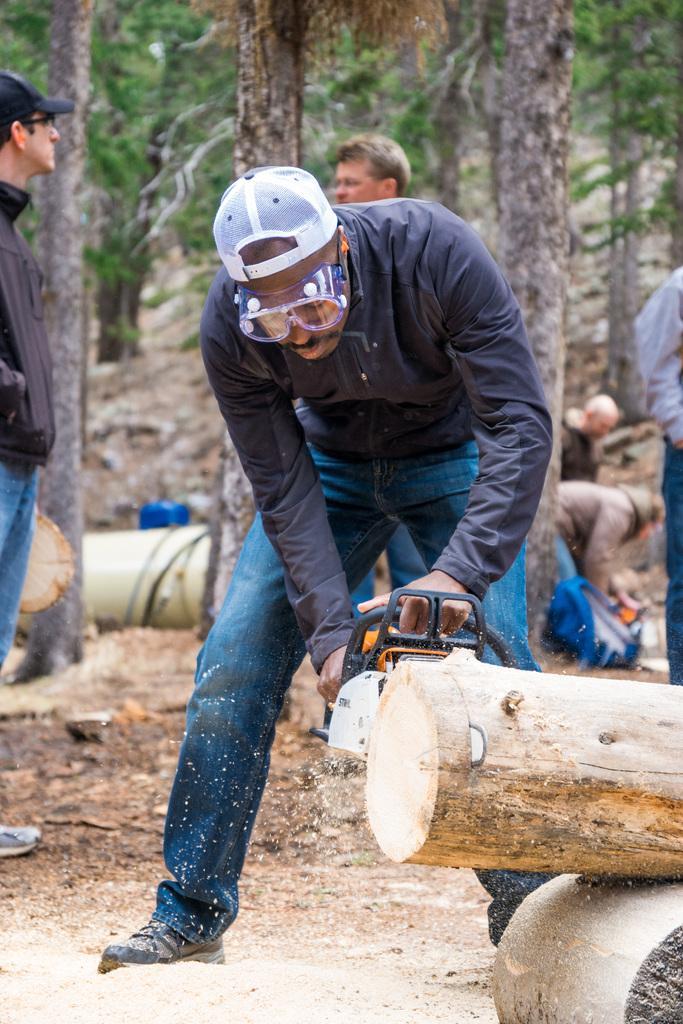Could you give a brief overview of what you see in this image? In the picture I can see people standing on the ground, among them a man is holding an object in hands. In the background I can see trees and some other things. 